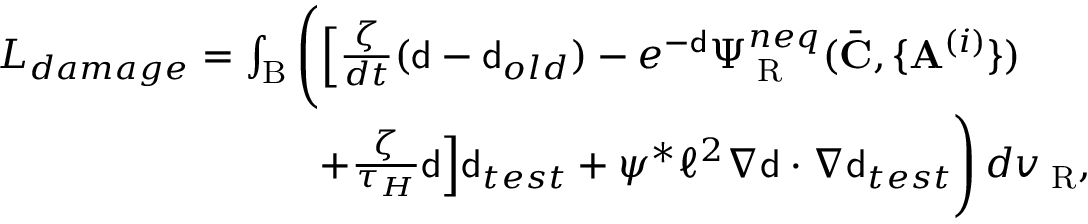Convert formula to latex. <formula><loc_0><loc_0><loc_500><loc_500>\begin{array} { r l } & { L _ { d a m a g e } = \int _ { B } \left ( \left [ \frac { \zeta } { d t } ( { d } - { d } _ { o l d } ) - e ^ { - { d } } \Psi _ { R } ^ { n e q } ( \bar { C } , \{ A ^ { ( i ) } \} ) } \\ & { \quad + \frac { \zeta } { \tau _ { H } } { d } \right ] { d } _ { t e s t } + \psi ^ { * } \ell ^ { 2 } \nabla { d } \cdot \nabla { d } _ { t e s t } \right ) \, d v _ { R } , } \end{array}</formula> 